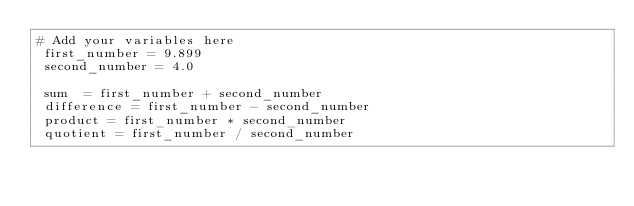Convert code to text. <code><loc_0><loc_0><loc_500><loc_500><_Ruby_># Add your variables here
 first_number = 9.899
 second_number = 4.0
 
 sum  = first_number + second_number
 difference = first_number - second_number
 product = first_number * second_number
 quotient = first_number / second_number</code> 